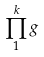<formula> <loc_0><loc_0><loc_500><loc_500>\prod _ { 1 } ^ { k } g</formula> 